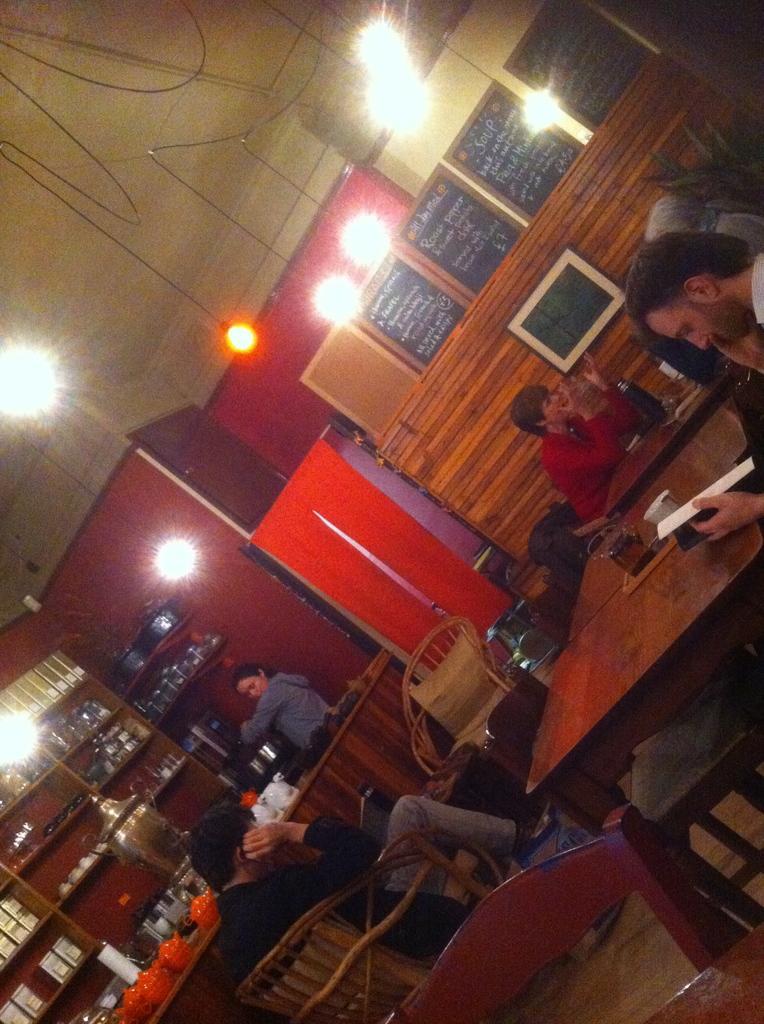Can you describe this image briefly? At the bottom right corner of the image there is a table and a chair. And to the right corner of the image there is a man sitting and holding the book in his hand. In front of him there is a table with a few items on it. Behind him there are two ladies sitting and in front of them there is a table. At the bottom left corner of the image there is a table with a few items on it. Behind the table there is a person standing, and also there is a cupboard with few items on it. In the background there is a red wall and also there are black boards with menu on it. And to the top of the image there is a roof with lights hanging to it. 